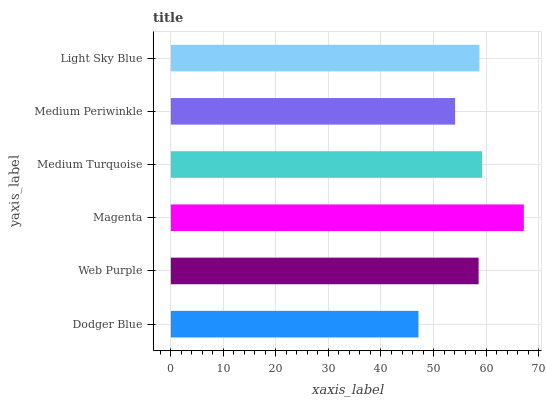Is Dodger Blue the minimum?
Answer yes or no. Yes. Is Magenta the maximum?
Answer yes or no. Yes. Is Web Purple the minimum?
Answer yes or no. No. Is Web Purple the maximum?
Answer yes or no. No. Is Web Purple greater than Dodger Blue?
Answer yes or no. Yes. Is Dodger Blue less than Web Purple?
Answer yes or no. Yes. Is Dodger Blue greater than Web Purple?
Answer yes or no. No. Is Web Purple less than Dodger Blue?
Answer yes or no. No. Is Light Sky Blue the high median?
Answer yes or no. Yes. Is Web Purple the low median?
Answer yes or no. Yes. Is Magenta the high median?
Answer yes or no. No. Is Medium Turquoise the low median?
Answer yes or no. No. 